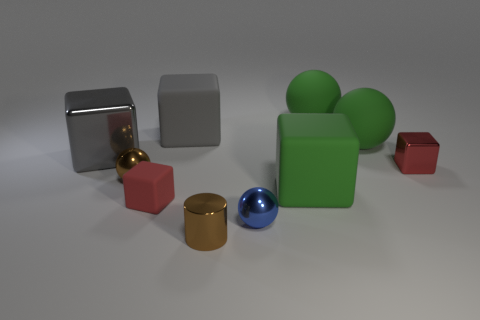Is there a green thing to the left of the gray thing behind the large metal cube behind the shiny cylinder?
Your answer should be compact. No. What is the material of the small sphere to the left of the blue sphere?
Your answer should be compact. Metal. There is a blue metallic object; does it have the same shape as the red object to the left of the cylinder?
Make the answer very short. No. Is the number of brown balls in front of the tiny blue thing the same as the number of small brown things on the right side of the small metallic cube?
Ensure brevity in your answer.  Yes. How many other things are there of the same material as the tiny blue thing?
Your answer should be compact. 4. What number of rubber objects are either blocks or big things?
Provide a short and direct response. 5. There is a large green thing in front of the large gray metal thing; is its shape the same as the blue shiny thing?
Make the answer very short. No. Is the number of big cubes right of the small brown metal ball greater than the number of tiny red rubber cubes?
Your answer should be very brief. Yes. What number of things are both in front of the large metal thing and right of the small rubber cube?
Offer a very short reply. 4. What color is the matte block to the right of the small thing in front of the blue sphere?
Provide a succinct answer. Green. 